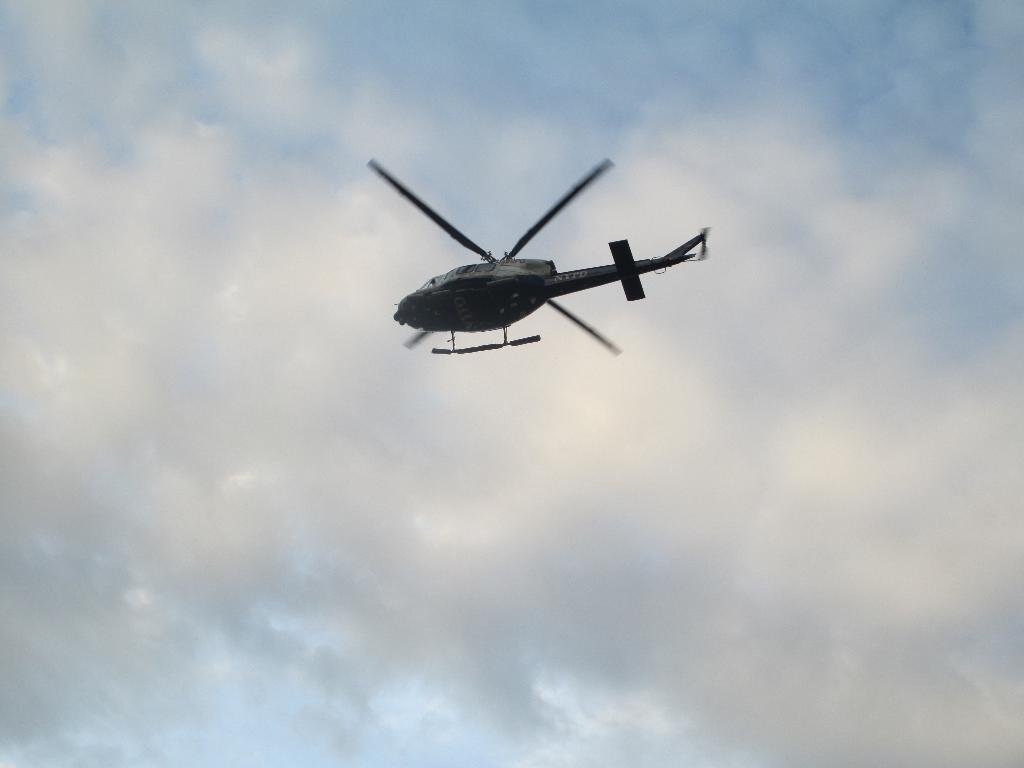Please provide a concise description of this image. In this picture we can see a helicopter flying in the sky with clouds. 